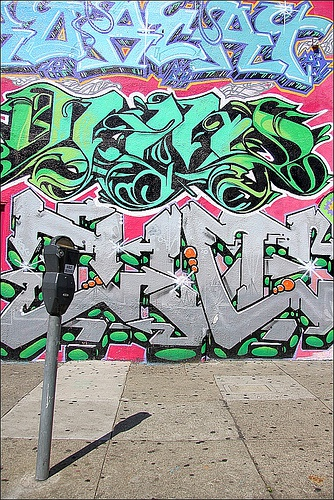Describe the objects in this image and their specific colors. I can see a parking meter in black, gray, and purple tones in this image. 